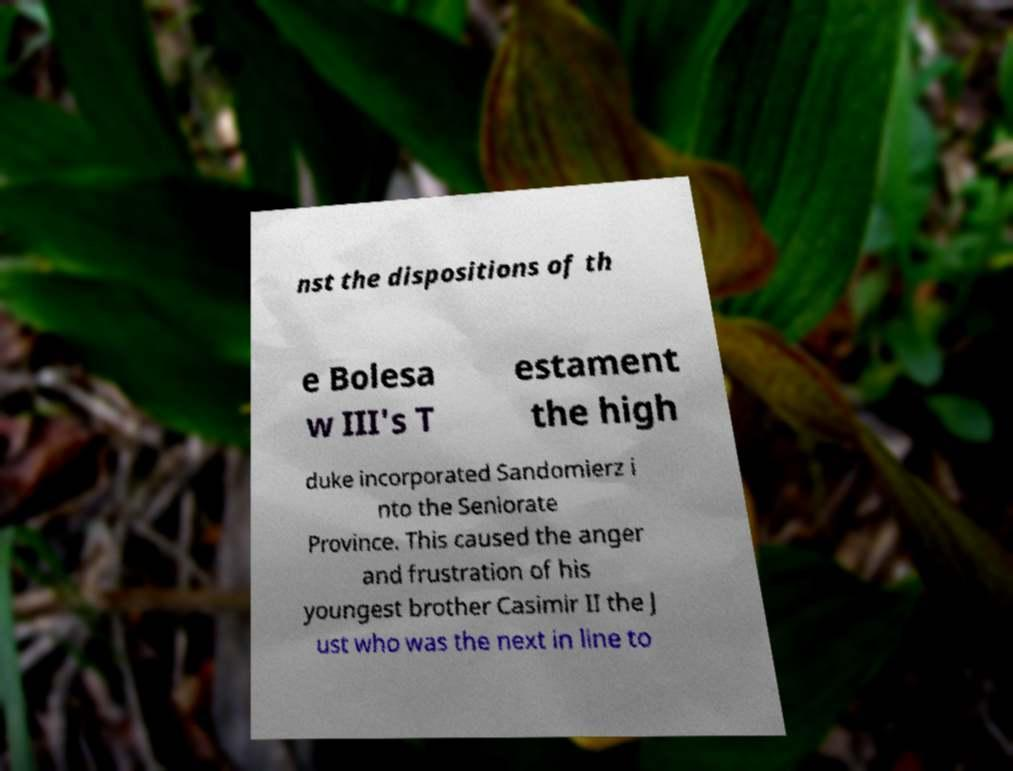For documentation purposes, I need the text within this image transcribed. Could you provide that? nst the dispositions of th e Bolesa w III's T estament the high duke incorporated Sandomierz i nto the Seniorate Province. This caused the anger and frustration of his youngest brother Casimir II the J ust who was the next in line to 